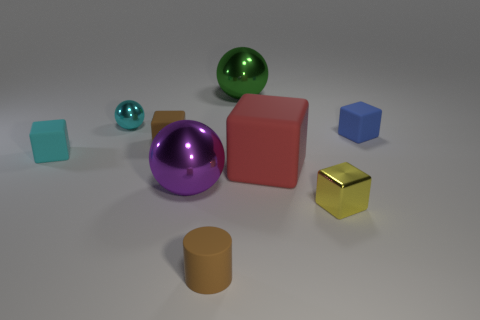How many red matte cubes have the same size as the brown matte cylinder?
Make the answer very short. 0. What is the small cyan cube made of?
Make the answer very short. Rubber. There is a large block; is its color the same as the big shiny ball that is behind the tiny cyan shiny sphere?
Ensure brevity in your answer.  No. Is there anything else that has the same size as the red rubber cube?
Your answer should be very brief. Yes. There is a rubber cube that is behind the small cyan block and in front of the small blue block; how big is it?
Offer a terse response. Small. The tiny yellow thing that is the same material as the large purple object is what shape?
Provide a short and direct response. Cube. Are the red cube and the tiny brown thing behind the large rubber thing made of the same material?
Your answer should be very brief. Yes. There is a small rubber object in front of the cyan rubber cube; are there any tiny yellow metal objects that are in front of it?
Your answer should be compact. No. There is a tiny thing that is the same shape as the large purple metal thing; what material is it?
Your answer should be compact. Metal. How many tiny brown objects are behind the small shiny thing that is right of the tiny cylinder?
Offer a terse response. 1. 